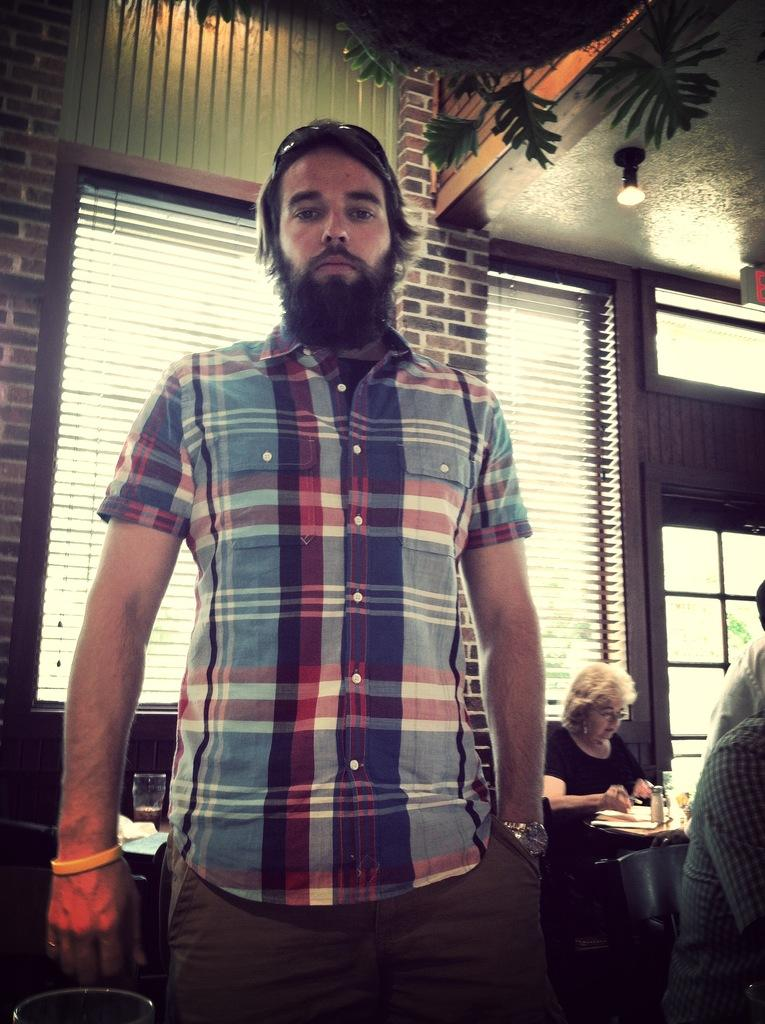Who is the main subject in the image? There is a man in the center of the image. Are there any other people visible in the image? Yes, there are other people on the right side of the image. What can be seen in the background of the image? There are windows in the background of the image. Where is the cactus located in the image? There is no cactus present in the image. How much water is visible in the image? There is no water visible in the image. 